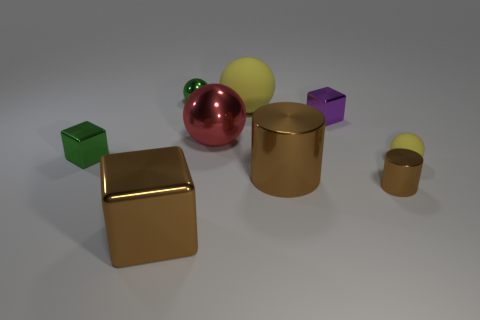Can you talk about the lighting and shadows in this image? The lighting in the image appears to come from the upper left, casting subtle shadows to the right of the objects, giving the scene a soft three-dimensional effect. 